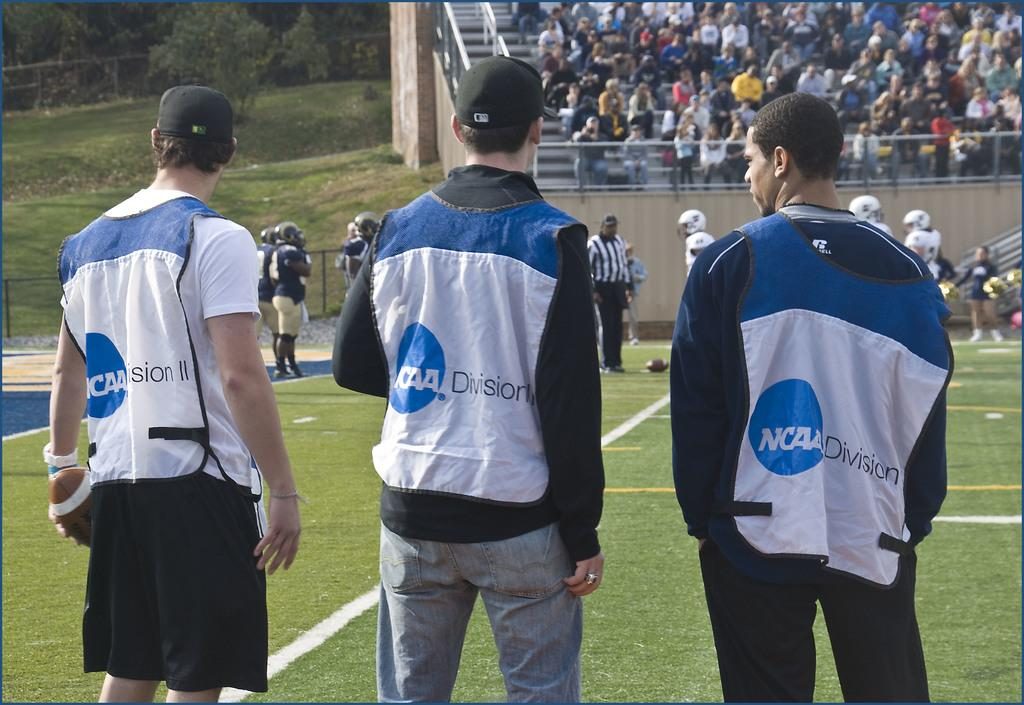Provide a one-sentence caption for the provided image. Three men with NCAA division on their clothing stand on a field. 